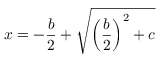<formula> <loc_0><loc_0><loc_500><loc_500>x = - { \frac { b } { 2 } } + { \sqrt { \left ( { \frac { b } { 2 } } \right ) ^ { 2 } + c } }</formula> 